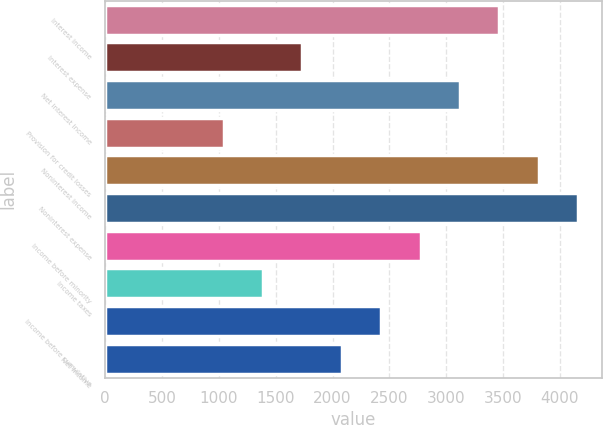<chart> <loc_0><loc_0><loc_500><loc_500><bar_chart><fcel>Interest income<fcel>Interest expense<fcel>Net interest income<fcel>Provision for credit losses<fcel>Noninterest income<fcel>Noninterest expense<fcel>Income before minority<fcel>Income taxes<fcel>Income before cumulative<fcel>Net income<nl><fcel>3467.04<fcel>1734.49<fcel>3120.53<fcel>1041.47<fcel>3813.55<fcel>4160.06<fcel>2774.02<fcel>1387.98<fcel>2427.51<fcel>2081<nl></chart> 